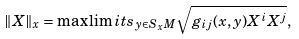<formula> <loc_0><loc_0><loc_500><loc_500>\| X \| _ { x } = \max \lim i t s _ { y \in S _ { x } M } \sqrt { g _ { i j } ( x , y ) X ^ { i } X ^ { j } } ,</formula> 